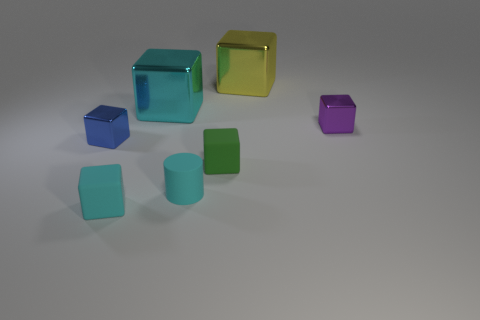Subtract all blue cubes. How many cubes are left? 5 Subtract 2 cubes. How many cubes are left? 4 Subtract all green matte cubes. How many cubes are left? 5 Subtract all gray blocks. Subtract all blue spheres. How many blocks are left? 6 Add 1 matte cylinders. How many objects exist? 8 Subtract all cylinders. How many objects are left? 6 Subtract 0 purple spheres. How many objects are left? 7 Subtract all tiny blue shiny cylinders. Subtract all metal objects. How many objects are left? 3 Add 7 tiny cyan cylinders. How many tiny cyan cylinders are left? 8 Add 2 large cyan cubes. How many large cyan cubes exist? 3 